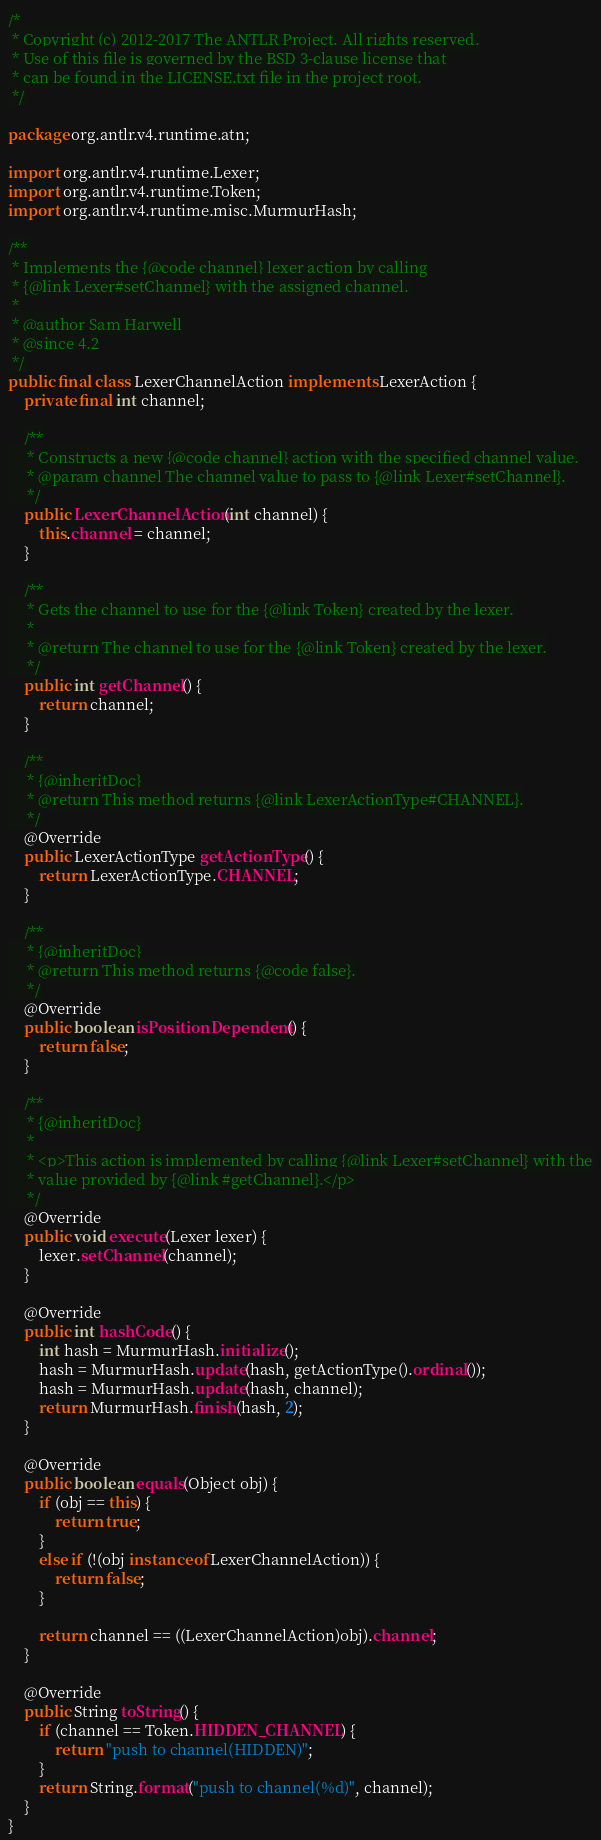Convert code to text. <code><loc_0><loc_0><loc_500><loc_500><_Java_>/*
 * Copyright (c) 2012-2017 The ANTLR Project. All rights reserved.
 * Use of this file is governed by the BSD 3-clause license that
 * can be found in the LICENSE.txt file in the project root.
 */

package org.antlr.v4.runtime.atn;

import org.antlr.v4.runtime.Lexer;
import org.antlr.v4.runtime.Token;
import org.antlr.v4.runtime.misc.MurmurHash;

/**
 * Implements the {@code channel} lexer action by calling
 * {@link Lexer#setChannel} with the assigned channel.
 *
 * @author Sam Harwell
 * @since 4.2
 */
public final class LexerChannelAction implements LexerAction {
	private final int channel;

	/**
	 * Constructs a new {@code channel} action with the specified channel value.
	 * @param channel The channel value to pass to {@link Lexer#setChannel}.
	 */
	public LexerChannelAction(int channel) {
		this.channel = channel;
	}

	/**
	 * Gets the channel to use for the {@link Token} created by the lexer.
	 *
	 * @return The channel to use for the {@link Token} created by the lexer.
	 */
	public int getChannel() {
		return channel;
	}

	/**
	 * {@inheritDoc}
	 * @return This method returns {@link LexerActionType#CHANNEL}.
	 */
	@Override
	public LexerActionType getActionType() {
		return LexerActionType.CHANNEL;
	}

	/**
	 * {@inheritDoc}
	 * @return This method returns {@code false}.
	 */
	@Override
	public boolean isPositionDependent() {
		return false;
	}

	/**
	 * {@inheritDoc}
	 *
	 * <p>This action is implemented by calling {@link Lexer#setChannel} with the
	 * value provided by {@link #getChannel}.</p>
	 */
	@Override
	public void execute(Lexer lexer) {
		lexer.setChannel(channel);
	}

	@Override
	public int hashCode() {
		int hash = MurmurHash.initialize();
		hash = MurmurHash.update(hash, getActionType().ordinal());
		hash = MurmurHash.update(hash, channel);
		return MurmurHash.finish(hash, 2);
	}

	@Override
	public boolean equals(Object obj) {
		if (obj == this) {
			return true;
		}
		else if (!(obj instanceof LexerChannelAction)) {
			return false;
		}

		return channel == ((LexerChannelAction)obj).channel;
	}

	@Override
	public String toString() {
		if (channel == Token.HIDDEN_CHANNEL) {
			return "push to channel(HIDDEN)";
		}
		return String.format("push to channel(%d)", channel);
	}
}
</code> 